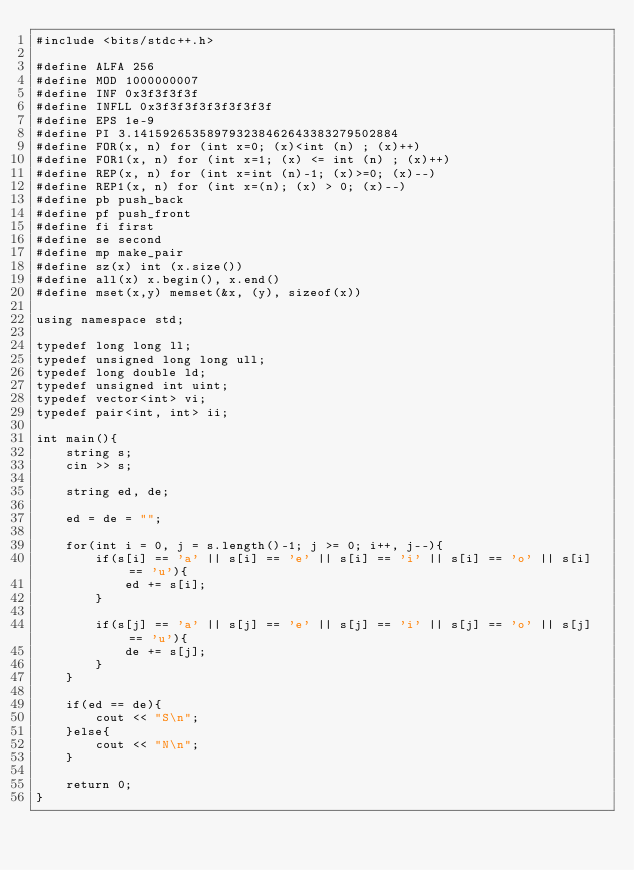Convert code to text. <code><loc_0><loc_0><loc_500><loc_500><_C++_>#include <bits/stdc++.h>

#define ALFA 256
#define MOD 1000000007
#define INF 0x3f3f3f3f
#define INFLL 0x3f3f3f3f3f3f3f3f
#define EPS 1e-9
#define PI 3.141592653589793238462643383279502884
#define FOR(x, n) for (int x=0; (x)<int (n) ; (x)++)
#define FOR1(x, n) for (int x=1; (x) <= int (n) ; (x)++)
#define REP(x, n) for (int x=int (n)-1; (x)>=0; (x)--)
#define REP1(x, n) for (int x=(n); (x) > 0; (x)--)
#define pb push_back
#define pf push_front
#define fi first
#define se second
#define mp make_pair
#define sz(x) int (x.size())
#define all(x) x.begin(), x.end()
#define mset(x,y) memset(&x, (y), sizeof(x))

using namespace std;

typedef long long ll;
typedef unsigned long long ull;
typedef long double ld;
typedef unsigned int uint;
typedef vector<int> vi;
typedef pair<int, int> ii;

int main(){
    string s;
    cin >> s;

    string ed, de;

    ed = de = "";

    for(int i = 0, j = s.length()-1; j >= 0; i++, j--){
        if(s[i] == 'a' || s[i] == 'e' || s[i] == 'i' || s[i] == 'o' || s[i] == 'u'){
            ed += s[i];
        }

        if(s[j] == 'a' || s[j] == 'e' || s[j] == 'i' || s[j] == 'o' || s[j] == 'u'){
            de += s[j];
        }
    }

    if(ed == de){
        cout << "S\n";
    }else{
        cout << "N\n";
    }

    return 0;
}</code> 